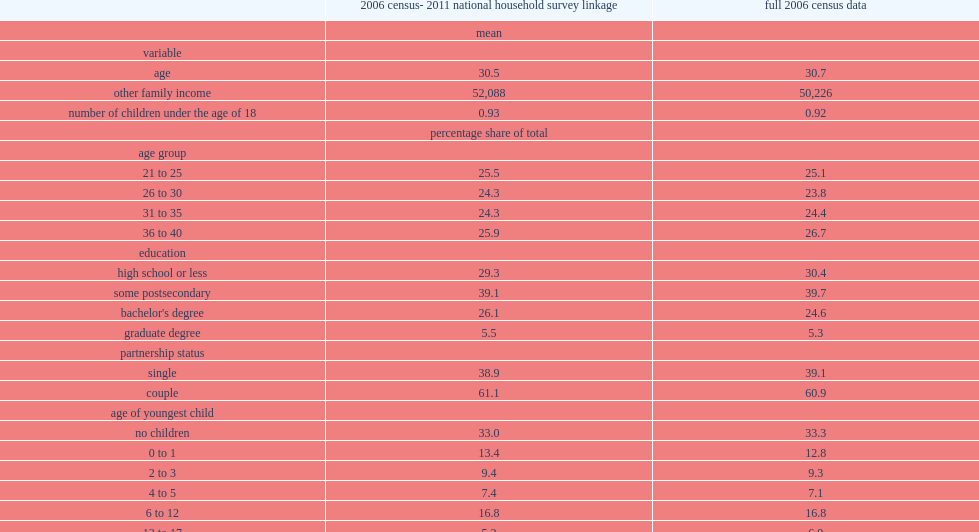What is the average age of women in the 2006 census- 2011 national household survey linkage? 30.5. What is ther percentage of women who had no postsecondary qualifications in the 2006 census- 2011 national household survey linkage samples? 29.3. What is the percentage of women who were single in the 2006 census-2011 national household survey linkage samples? 38.9. What is the average number of children under the age of 18 in the 2006 census- 2011 national household survey linkage samples? 0.93. What is the percentage of the working women who are wage earners in the 2006 census- 2011 national household survey linkage samples? 93.4. What is the percentage of working women who are wage earners in the full 2006 census data? 93.4. What is the percentage of self-employed women who are incorporated in the 2006 census- 2011 national household survey linkage samples? 1.5. What is the percentage of self-employed women who are unincorporated in the 2006 census- 2011 national household survey linkage samples? 5.1. What is the percentage of self-employed women who are incorporated in the full 2006 census data? 1.6. What is the percentage of self-employed women who are unincorporated in the full 2006 census data? 5.0. 